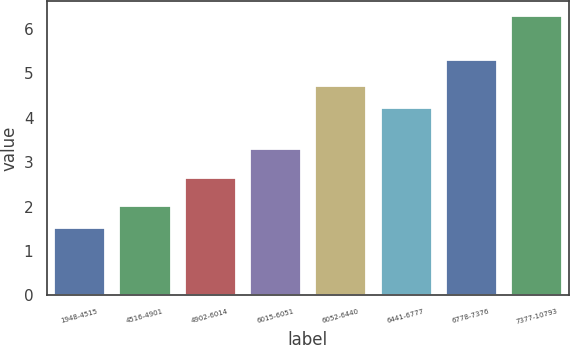Convert chart. <chart><loc_0><loc_0><loc_500><loc_500><bar_chart><fcel>1948-4515<fcel>4516-4901<fcel>4902-6014<fcel>6015-6051<fcel>6052-6440<fcel>6441-6777<fcel>6778-7376<fcel>7377-10793<nl><fcel>1.55<fcel>2.03<fcel>2.66<fcel>3.32<fcel>4.73<fcel>4.25<fcel>5.33<fcel>6.31<nl></chart> 